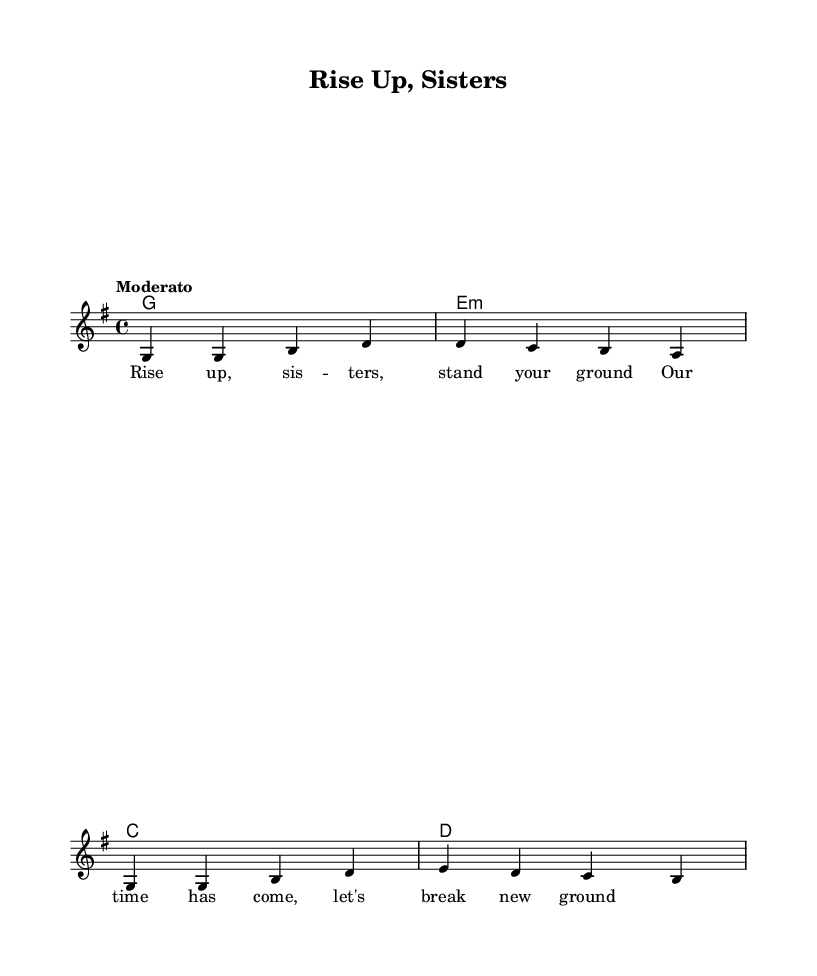What is the key signature of this music? The key signature is G major, which has one sharp, F#. This is identified by looking at the key signature indicated at the beginning of the staff, where the F# is the only sharp present.
Answer: G major What is the time signature of this music? The time signature is 4/4, which is indicated at the beginning of the score. This means there are four beats in each measure, and the quarter note gets one beat.
Answer: 4/4 What is the tempo marking for this piece? The tempo marking is "Moderato," which directs the performer to play at a moderate speed. This is explicitly stated in the notation near the beginning of the piece.
Answer: Moderato How many measures are in the melody? The melody consists of four measures. This can be counted by identifying the vertical lines that separate each measure in the staff notation.
Answer: 4 What is the first lyric line of the verse? The first lyric line of the verse is "Rise up, sisters, stand your ground." This is located directly below the melody line and matches the rhythm and phrasing of the musical notes above it.
Answer: Rise up, sisters, stand your ground What chords are used in the harmony section? The chords used in the harmony section are G, E minor, C, and D. These can be seen as the chord symbols above the melody, outlining the harmonic structure beneath the vocal part.
Answer: G, E minor, C, D What theme does this piece celebrate? The piece celebrates women's rights and achievements, as indicated by the title "Rise Up, Sisters" and the lyrics that call for empowerment and unity among women. This context can be inferred from the lyrical content and overall message of the piece.
Answer: Women's rights and achievements 